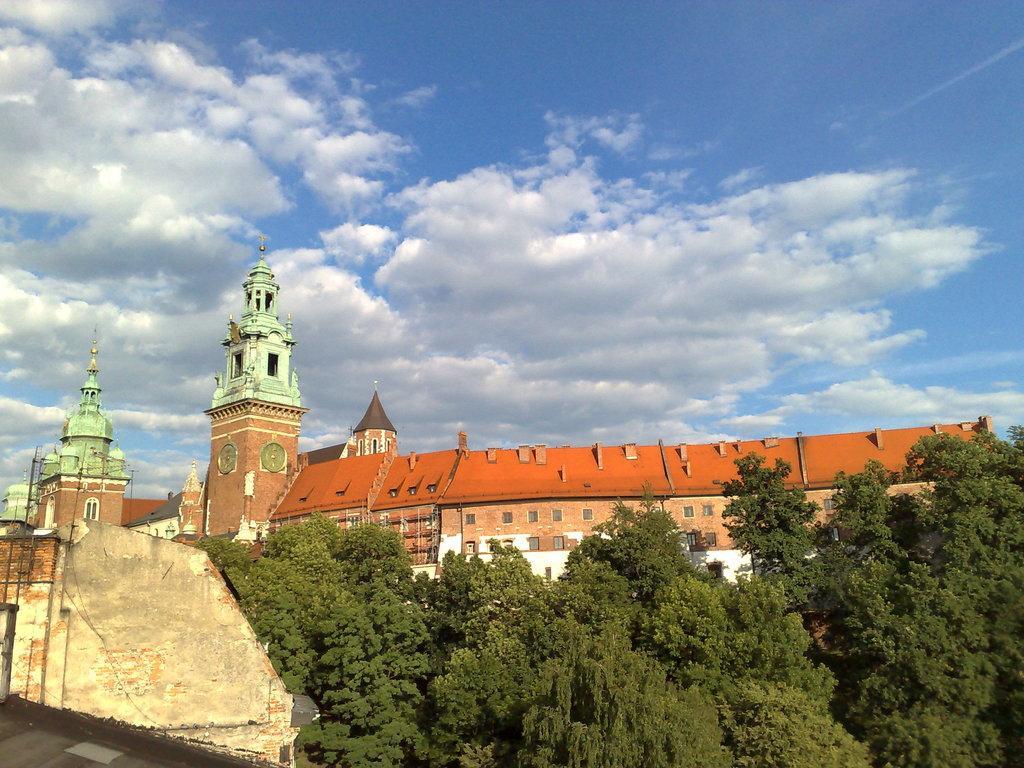Can you describe this image briefly? Here we can see trees and buildings. In the background there is sky with clouds. 